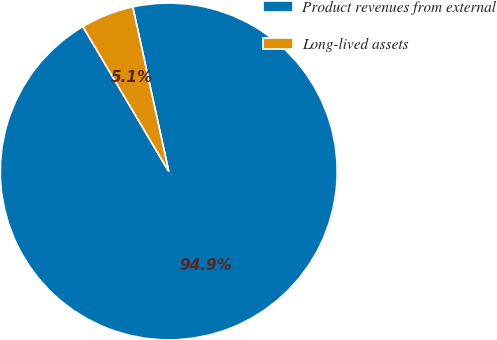<chart> <loc_0><loc_0><loc_500><loc_500><pie_chart><fcel>Product revenues from external<fcel>Long-lived assets<nl><fcel>94.91%<fcel>5.09%<nl></chart> 